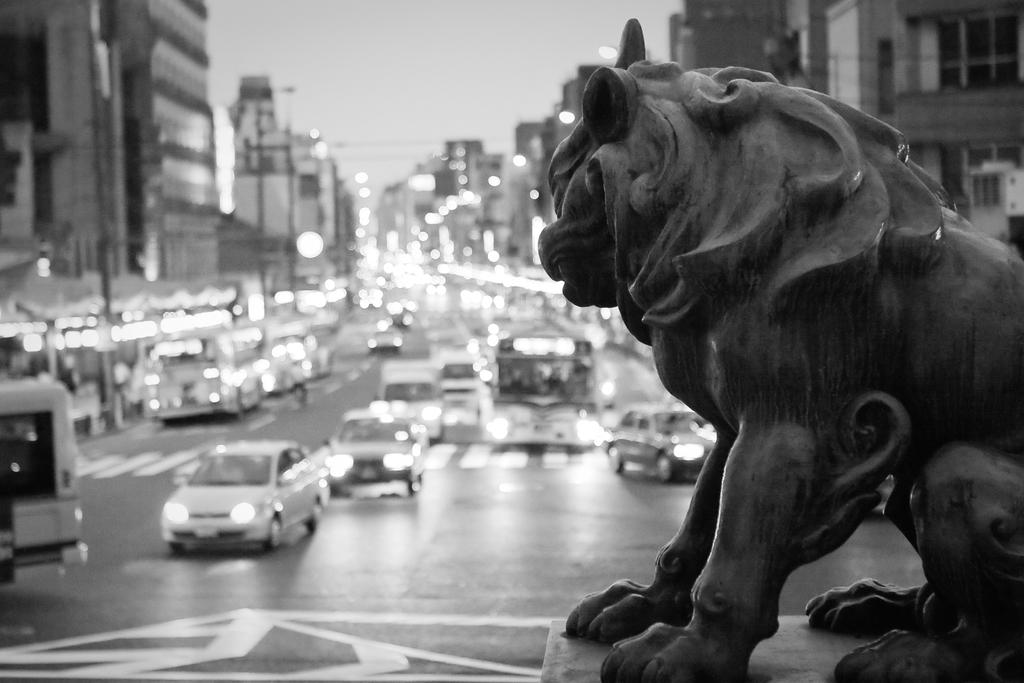What is the main subject in the image? There is a statue in the image. What else can be seen in the image besides the statue? There are vehicles on the road and buildings in the background of the image. What is visible in the sky in the image? The sky is visible in the background of the image. What flavor of jam is being served during the recess in the image? There is no mention of recess or jam in the image; it features a statue, vehicles, buildings, and the sky. 